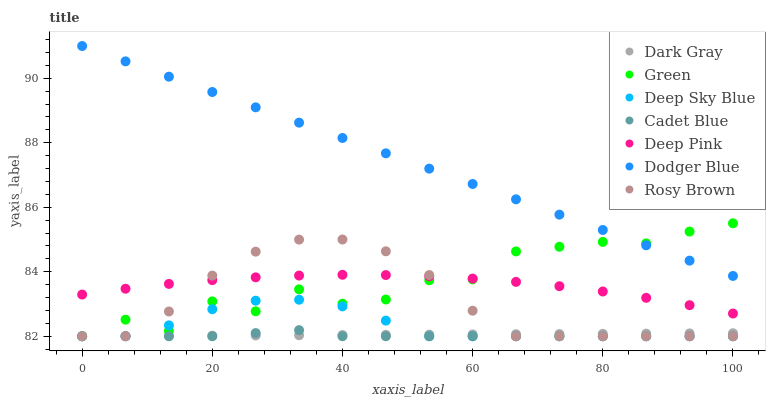Does Cadet Blue have the minimum area under the curve?
Answer yes or no. Yes. Does Dodger Blue have the maximum area under the curve?
Answer yes or no. Yes. Does Rosy Brown have the minimum area under the curve?
Answer yes or no. No. Does Rosy Brown have the maximum area under the curve?
Answer yes or no. No. Is Dark Gray the smoothest?
Answer yes or no. Yes. Is Green the roughest?
Answer yes or no. Yes. Is Rosy Brown the smoothest?
Answer yes or no. No. Is Rosy Brown the roughest?
Answer yes or no. No. Does Cadet Blue have the lowest value?
Answer yes or no. Yes. Does Deep Pink have the lowest value?
Answer yes or no. No. Does Dodger Blue have the highest value?
Answer yes or no. Yes. Does Rosy Brown have the highest value?
Answer yes or no. No. Is Dark Gray less than Dodger Blue?
Answer yes or no. Yes. Is Dodger Blue greater than Rosy Brown?
Answer yes or no. Yes. Does Rosy Brown intersect Cadet Blue?
Answer yes or no. Yes. Is Rosy Brown less than Cadet Blue?
Answer yes or no. No. Is Rosy Brown greater than Cadet Blue?
Answer yes or no. No. Does Dark Gray intersect Dodger Blue?
Answer yes or no. No. 